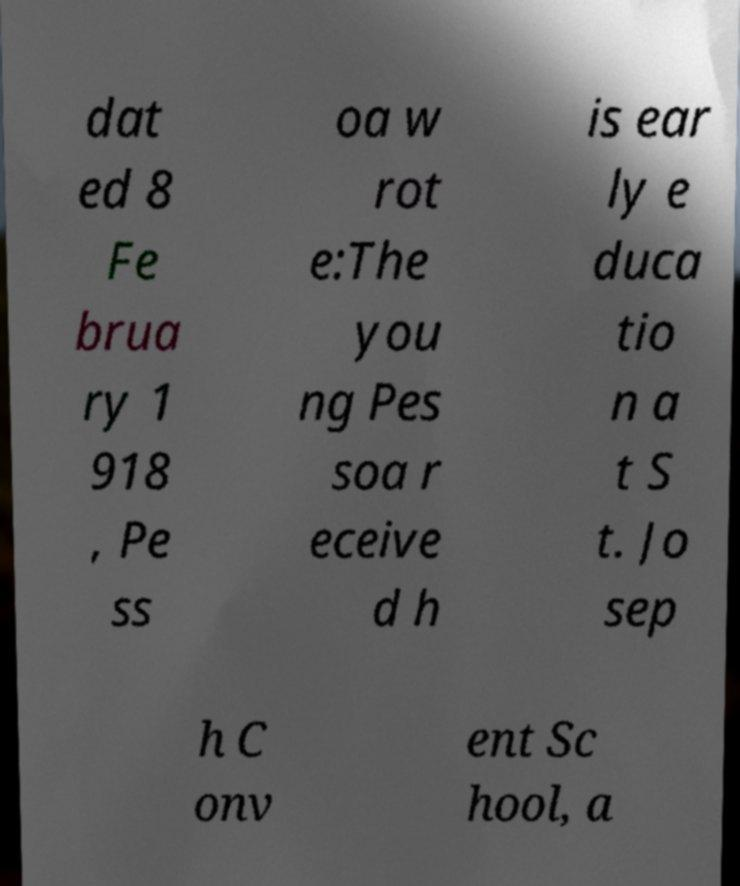Could you extract and type out the text from this image? dat ed 8 Fe brua ry 1 918 , Pe ss oa w rot e:The you ng Pes soa r eceive d h is ear ly e duca tio n a t S t. Jo sep h C onv ent Sc hool, a 